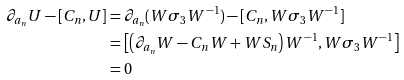<formula> <loc_0><loc_0><loc_500><loc_500>\partial _ { a _ { n } } U - [ C _ { n } , U ] & = \partial _ { a _ { n } } ( W \sigma _ { 3 } W ^ { - 1 } ) - [ C _ { n } , W \sigma _ { 3 } W ^ { - 1 } ] \\ & = \left [ \left ( \partial _ { a _ { n } } W - C _ { n } W + W S _ { n } \right ) W ^ { - 1 } , W \sigma _ { 3 } W ^ { - 1 } \right ] \\ & = 0</formula> 